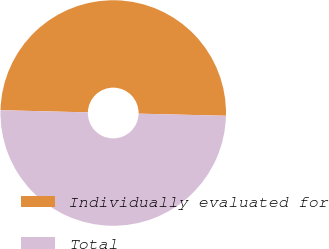Convert chart. <chart><loc_0><loc_0><loc_500><loc_500><pie_chart><fcel>Individually evaluated for<fcel>Total<nl><fcel>49.99%<fcel>50.01%<nl></chart> 